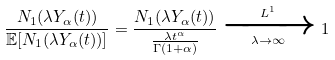<formula> <loc_0><loc_0><loc_500><loc_500>\frac { N _ { 1 } ( \lambda Y _ { \alpha } ( t ) ) } { \mathbb { E } [ N _ { 1 } ( \lambda Y _ { \alpha } ( t ) ) ] } = \frac { N _ { 1 } ( \lambda Y _ { \alpha } ( t ) ) } { \frac { \lambda t ^ { \alpha } } { \Gamma ( 1 + \alpha ) } } \xrightarrow [ \lambda \to \infty ] { L ^ { 1 } } 1</formula> 